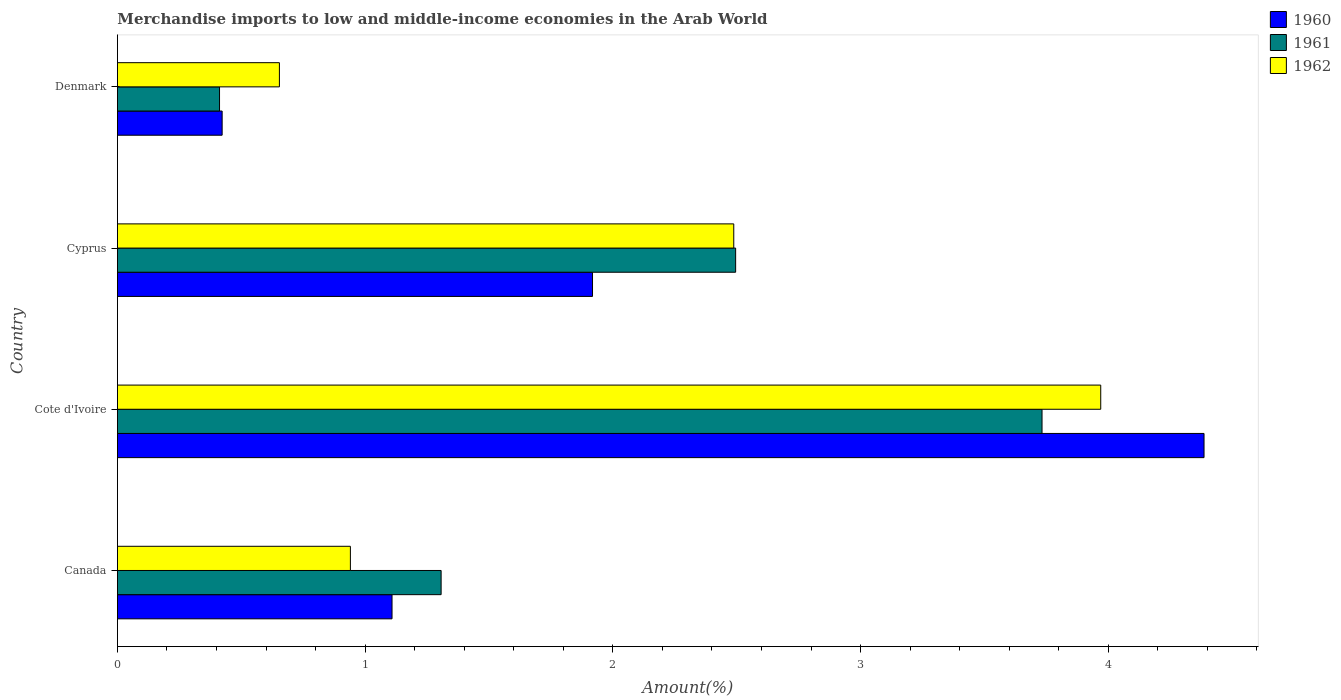How many different coloured bars are there?
Make the answer very short. 3. Are the number of bars on each tick of the Y-axis equal?
Your answer should be compact. Yes. How many bars are there on the 1st tick from the top?
Make the answer very short. 3. How many bars are there on the 1st tick from the bottom?
Offer a very short reply. 3. What is the label of the 2nd group of bars from the top?
Ensure brevity in your answer.  Cyprus. In how many cases, is the number of bars for a given country not equal to the number of legend labels?
Give a very brief answer. 0. What is the percentage of amount earned from merchandise imports in 1961 in Denmark?
Ensure brevity in your answer.  0.41. Across all countries, what is the maximum percentage of amount earned from merchandise imports in 1961?
Your answer should be compact. 3.73. Across all countries, what is the minimum percentage of amount earned from merchandise imports in 1960?
Offer a very short reply. 0.42. In which country was the percentage of amount earned from merchandise imports in 1961 maximum?
Your answer should be very brief. Cote d'Ivoire. What is the total percentage of amount earned from merchandise imports in 1962 in the graph?
Offer a very short reply. 8.05. What is the difference between the percentage of amount earned from merchandise imports in 1962 in Cote d'Ivoire and that in Cyprus?
Give a very brief answer. 1.48. What is the difference between the percentage of amount earned from merchandise imports in 1962 in Cyprus and the percentage of amount earned from merchandise imports in 1960 in Cote d'Ivoire?
Offer a terse response. -1.9. What is the average percentage of amount earned from merchandise imports in 1960 per country?
Ensure brevity in your answer.  1.96. What is the difference between the percentage of amount earned from merchandise imports in 1961 and percentage of amount earned from merchandise imports in 1962 in Denmark?
Your response must be concise. -0.24. What is the ratio of the percentage of amount earned from merchandise imports in 1962 in Canada to that in Cyprus?
Offer a very short reply. 0.38. Is the percentage of amount earned from merchandise imports in 1962 in Canada less than that in Denmark?
Keep it short and to the point. No. What is the difference between the highest and the second highest percentage of amount earned from merchandise imports in 1962?
Provide a short and direct response. 1.48. What is the difference between the highest and the lowest percentage of amount earned from merchandise imports in 1962?
Give a very brief answer. 3.32. Is the sum of the percentage of amount earned from merchandise imports in 1962 in Cyprus and Denmark greater than the maximum percentage of amount earned from merchandise imports in 1960 across all countries?
Your response must be concise. No. What does the 2nd bar from the bottom in Cyprus represents?
Offer a terse response. 1961. How many bars are there?
Your answer should be compact. 12. Are all the bars in the graph horizontal?
Provide a succinct answer. Yes. Does the graph contain any zero values?
Your answer should be very brief. No. Does the graph contain grids?
Provide a short and direct response. No. How are the legend labels stacked?
Your answer should be compact. Vertical. What is the title of the graph?
Ensure brevity in your answer.  Merchandise imports to low and middle-income economies in the Arab World. Does "1989" appear as one of the legend labels in the graph?
Ensure brevity in your answer.  No. What is the label or title of the X-axis?
Your answer should be compact. Amount(%). What is the label or title of the Y-axis?
Provide a short and direct response. Country. What is the Amount(%) in 1960 in Canada?
Ensure brevity in your answer.  1.11. What is the Amount(%) of 1961 in Canada?
Provide a short and direct response. 1.31. What is the Amount(%) in 1962 in Canada?
Your answer should be very brief. 0.94. What is the Amount(%) in 1960 in Cote d'Ivoire?
Offer a terse response. 4.39. What is the Amount(%) of 1961 in Cote d'Ivoire?
Your response must be concise. 3.73. What is the Amount(%) of 1962 in Cote d'Ivoire?
Your answer should be very brief. 3.97. What is the Amount(%) in 1960 in Cyprus?
Your answer should be compact. 1.92. What is the Amount(%) in 1961 in Cyprus?
Make the answer very short. 2.5. What is the Amount(%) in 1962 in Cyprus?
Your answer should be very brief. 2.49. What is the Amount(%) in 1960 in Denmark?
Provide a short and direct response. 0.42. What is the Amount(%) in 1961 in Denmark?
Your answer should be compact. 0.41. What is the Amount(%) in 1962 in Denmark?
Your response must be concise. 0.65. Across all countries, what is the maximum Amount(%) in 1960?
Your response must be concise. 4.39. Across all countries, what is the maximum Amount(%) in 1961?
Your response must be concise. 3.73. Across all countries, what is the maximum Amount(%) in 1962?
Make the answer very short. 3.97. Across all countries, what is the minimum Amount(%) in 1960?
Make the answer very short. 0.42. Across all countries, what is the minimum Amount(%) of 1961?
Ensure brevity in your answer.  0.41. Across all countries, what is the minimum Amount(%) of 1962?
Offer a very short reply. 0.65. What is the total Amount(%) of 1960 in the graph?
Make the answer very short. 7.84. What is the total Amount(%) in 1961 in the graph?
Make the answer very short. 7.95. What is the total Amount(%) of 1962 in the graph?
Provide a short and direct response. 8.05. What is the difference between the Amount(%) of 1960 in Canada and that in Cote d'Ivoire?
Your response must be concise. -3.28. What is the difference between the Amount(%) of 1961 in Canada and that in Cote d'Ivoire?
Your answer should be very brief. -2.43. What is the difference between the Amount(%) in 1962 in Canada and that in Cote d'Ivoire?
Make the answer very short. -3.03. What is the difference between the Amount(%) in 1960 in Canada and that in Cyprus?
Offer a very short reply. -0.81. What is the difference between the Amount(%) of 1961 in Canada and that in Cyprus?
Ensure brevity in your answer.  -1.19. What is the difference between the Amount(%) of 1962 in Canada and that in Cyprus?
Give a very brief answer. -1.55. What is the difference between the Amount(%) in 1960 in Canada and that in Denmark?
Your answer should be very brief. 0.69. What is the difference between the Amount(%) in 1961 in Canada and that in Denmark?
Offer a terse response. 0.89. What is the difference between the Amount(%) of 1962 in Canada and that in Denmark?
Your response must be concise. 0.29. What is the difference between the Amount(%) in 1960 in Cote d'Ivoire and that in Cyprus?
Ensure brevity in your answer.  2.47. What is the difference between the Amount(%) of 1961 in Cote d'Ivoire and that in Cyprus?
Your response must be concise. 1.24. What is the difference between the Amount(%) in 1962 in Cote d'Ivoire and that in Cyprus?
Make the answer very short. 1.48. What is the difference between the Amount(%) of 1960 in Cote d'Ivoire and that in Denmark?
Your answer should be compact. 3.96. What is the difference between the Amount(%) of 1961 in Cote d'Ivoire and that in Denmark?
Offer a terse response. 3.32. What is the difference between the Amount(%) of 1962 in Cote d'Ivoire and that in Denmark?
Provide a short and direct response. 3.32. What is the difference between the Amount(%) in 1960 in Cyprus and that in Denmark?
Provide a short and direct response. 1.5. What is the difference between the Amount(%) in 1961 in Cyprus and that in Denmark?
Offer a very short reply. 2.08. What is the difference between the Amount(%) in 1962 in Cyprus and that in Denmark?
Offer a very short reply. 1.83. What is the difference between the Amount(%) of 1960 in Canada and the Amount(%) of 1961 in Cote d'Ivoire?
Ensure brevity in your answer.  -2.62. What is the difference between the Amount(%) in 1960 in Canada and the Amount(%) in 1962 in Cote d'Ivoire?
Your answer should be compact. -2.86. What is the difference between the Amount(%) in 1961 in Canada and the Amount(%) in 1962 in Cote d'Ivoire?
Provide a succinct answer. -2.66. What is the difference between the Amount(%) of 1960 in Canada and the Amount(%) of 1961 in Cyprus?
Provide a succinct answer. -1.39. What is the difference between the Amount(%) of 1960 in Canada and the Amount(%) of 1962 in Cyprus?
Offer a terse response. -1.38. What is the difference between the Amount(%) in 1961 in Canada and the Amount(%) in 1962 in Cyprus?
Offer a terse response. -1.18. What is the difference between the Amount(%) of 1960 in Canada and the Amount(%) of 1961 in Denmark?
Ensure brevity in your answer.  0.7. What is the difference between the Amount(%) in 1960 in Canada and the Amount(%) in 1962 in Denmark?
Make the answer very short. 0.45. What is the difference between the Amount(%) of 1961 in Canada and the Amount(%) of 1962 in Denmark?
Provide a short and direct response. 0.65. What is the difference between the Amount(%) in 1960 in Cote d'Ivoire and the Amount(%) in 1961 in Cyprus?
Provide a short and direct response. 1.89. What is the difference between the Amount(%) in 1960 in Cote d'Ivoire and the Amount(%) in 1962 in Cyprus?
Give a very brief answer. 1.9. What is the difference between the Amount(%) of 1961 in Cote d'Ivoire and the Amount(%) of 1962 in Cyprus?
Provide a succinct answer. 1.24. What is the difference between the Amount(%) in 1960 in Cote d'Ivoire and the Amount(%) in 1961 in Denmark?
Offer a terse response. 3.97. What is the difference between the Amount(%) in 1960 in Cote d'Ivoire and the Amount(%) in 1962 in Denmark?
Provide a succinct answer. 3.73. What is the difference between the Amount(%) in 1961 in Cote d'Ivoire and the Amount(%) in 1962 in Denmark?
Your answer should be compact. 3.08. What is the difference between the Amount(%) in 1960 in Cyprus and the Amount(%) in 1961 in Denmark?
Make the answer very short. 1.51. What is the difference between the Amount(%) in 1960 in Cyprus and the Amount(%) in 1962 in Denmark?
Keep it short and to the point. 1.26. What is the difference between the Amount(%) in 1961 in Cyprus and the Amount(%) in 1962 in Denmark?
Your response must be concise. 1.84. What is the average Amount(%) in 1960 per country?
Make the answer very short. 1.96. What is the average Amount(%) in 1961 per country?
Make the answer very short. 1.99. What is the average Amount(%) in 1962 per country?
Make the answer very short. 2.01. What is the difference between the Amount(%) of 1960 and Amount(%) of 1961 in Canada?
Offer a terse response. -0.2. What is the difference between the Amount(%) of 1960 and Amount(%) of 1962 in Canada?
Provide a short and direct response. 0.17. What is the difference between the Amount(%) of 1961 and Amount(%) of 1962 in Canada?
Keep it short and to the point. 0.37. What is the difference between the Amount(%) of 1960 and Amount(%) of 1961 in Cote d'Ivoire?
Provide a short and direct response. 0.65. What is the difference between the Amount(%) in 1960 and Amount(%) in 1962 in Cote d'Ivoire?
Give a very brief answer. 0.42. What is the difference between the Amount(%) of 1961 and Amount(%) of 1962 in Cote d'Ivoire?
Your answer should be very brief. -0.24. What is the difference between the Amount(%) of 1960 and Amount(%) of 1961 in Cyprus?
Ensure brevity in your answer.  -0.58. What is the difference between the Amount(%) of 1960 and Amount(%) of 1962 in Cyprus?
Your answer should be very brief. -0.57. What is the difference between the Amount(%) in 1961 and Amount(%) in 1962 in Cyprus?
Your answer should be very brief. 0.01. What is the difference between the Amount(%) of 1960 and Amount(%) of 1961 in Denmark?
Make the answer very short. 0.01. What is the difference between the Amount(%) in 1960 and Amount(%) in 1962 in Denmark?
Your answer should be compact. -0.23. What is the difference between the Amount(%) in 1961 and Amount(%) in 1962 in Denmark?
Keep it short and to the point. -0.24. What is the ratio of the Amount(%) of 1960 in Canada to that in Cote d'Ivoire?
Your answer should be compact. 0.25. What is the ratio of the Amount(%) of 1961 in Canada to that in Cote d'Ivoire?
Keep it short and to the point. 0.35. What is the ratio of the Amount(%) of 1962 in Canada to that in Cote d'Ivoire?
Ensure brevity in your answer.  0.24. What is the ratio of the Amount(%) of 1960 in Canada to that in Cyprus?
Provide a succinct answer. 0.58. What is the ratio of the Amount(%) of 1961 in Canada to that in Cyprus?
Your response must be concise. 0.52. What is the ratio of the Amount(%) of 1962 in Canada to that in Cyprus?
Give a very brief answer. 0.38. What is the ratio of the Amount(%) in 1960 in Canada to that in Denmark?
Provide a succinct answer. 2.62. What is the ratio of the Amount(%) of 1961 in Canada to that in Denmark?
Ensure brevity in your answer.  3.17. What is the ratio of the Amount(%) of 1962 in Canada to that in Denmark?
Provide a short and direct response. 1.44. What is the ratio of the Amount(%) of 1960 in Cote d'Ivoire to that in Cyprus?
Your answer should be compact. 2.29. What is the ratio of the Amount(%) of 1961 in Cote d'Ivoire to that in Cyprus?
Provide a succinct answer. 1.5. What is the ratio of the Amount(%) of 1962 in Cote d'Ivoire to that in Cyprus?
Give a very brief answer. 1.6. What is the ratio of the Amount(%) in 1960 in Cote d'Ivoire to that in Denmark?
Give a very brief answer. 10.37. What is the ratio of the Amount(%) of 1961 in Cote d'Ivoire to that in Denmark?
Ensure brevity in your answer.  9.05. What is the ratio of the Amount(%) in 1962 in Cote d'Ivoire to that in Denmark?
Ensure brevity in your answer.  6.07. What is the ratio of the Amount(%) of 1960 in Cyprus to that in Denmark?
Provide a short and direct response. 4.54. What is the ratio of the Amount(%) in 1961 in Cyprus to that in Denmark?
Ensure brevity in your answer.  6.05. What is the ratio of the Amount(%) in 1962 in Cyprus to that in Denmark?
Your answer should be compact. 3.8. What is the difference between the highest and the second highest Amount(%) in 1960?
Keep it short and to the point. 2.47. What is the difference between the highest and the second highest Amount(%) of 1961?
Your answer should be very brief. 1.24. What is the difference between the highest and the second highest Amount(%) of 1962?
Your response must be concise. 1.48. What is the difference between the highest and the lowest Amount(%) in 1960?
Your answer should be very brief. 3.96. What is the difference between the highest and the lowest Amount(%) of 1961?
Make the answer very short. 3.32. What is the difference between the highest and the lowest Amount(%) of 1962?
Provide a succinct answer. 3.32. 